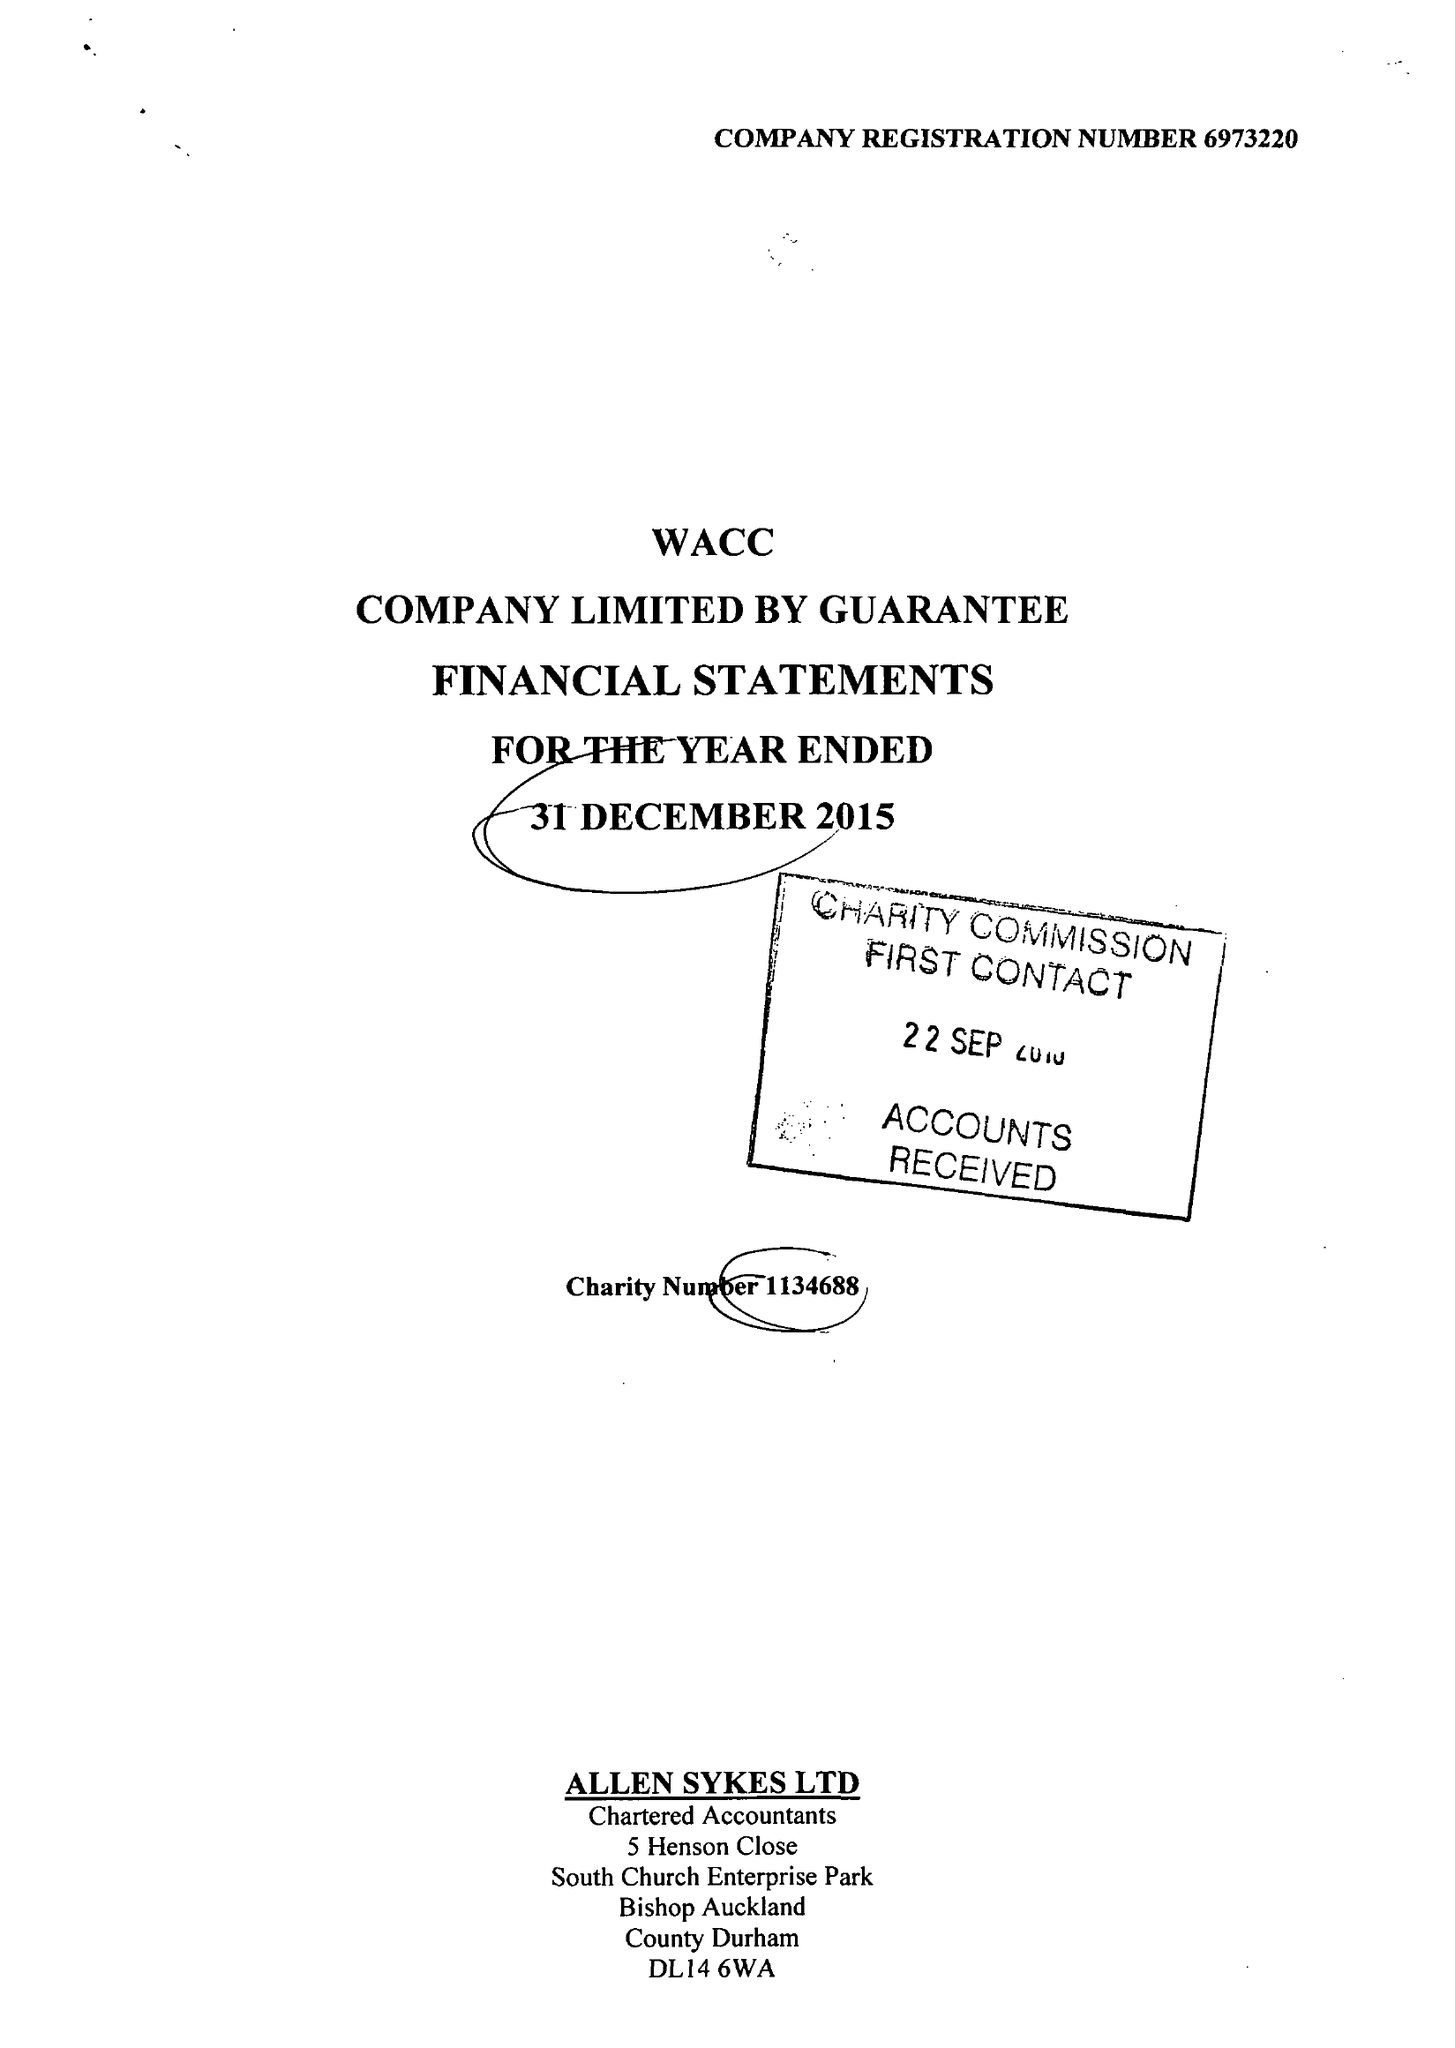What is the value for the income_annually_in_british_pounds?
Answer the question using a single word or phrase. 196000.00 